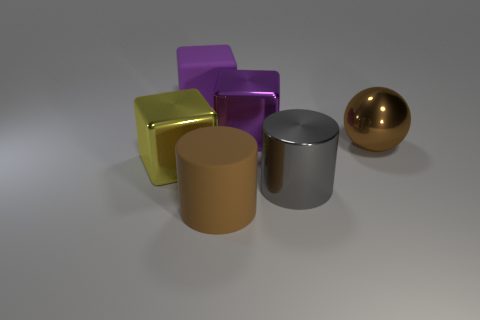Add 3 cubes. How many objects exist? 9 Subtract all balls. How many objects are left? 5 Subtract 0 purple cylinders. How many objects are left? 6 Subtract all big purple objects. Subtract all purple shiny objects. How many objects are left? 3 Add 5 gray cylinders. How many gray cylinders are left? 6 Add 2 large red cylinders. How many large red cylinders exist? 2 